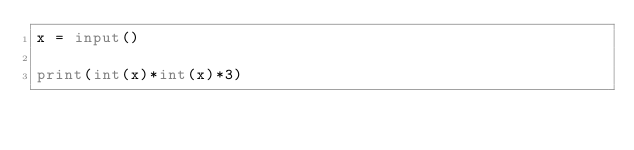Convert code to text. <code><loc_0><loc_0><loc_500><loc_500><_Python_>x = input()

print(int(x)*int(x)*3)</code> 